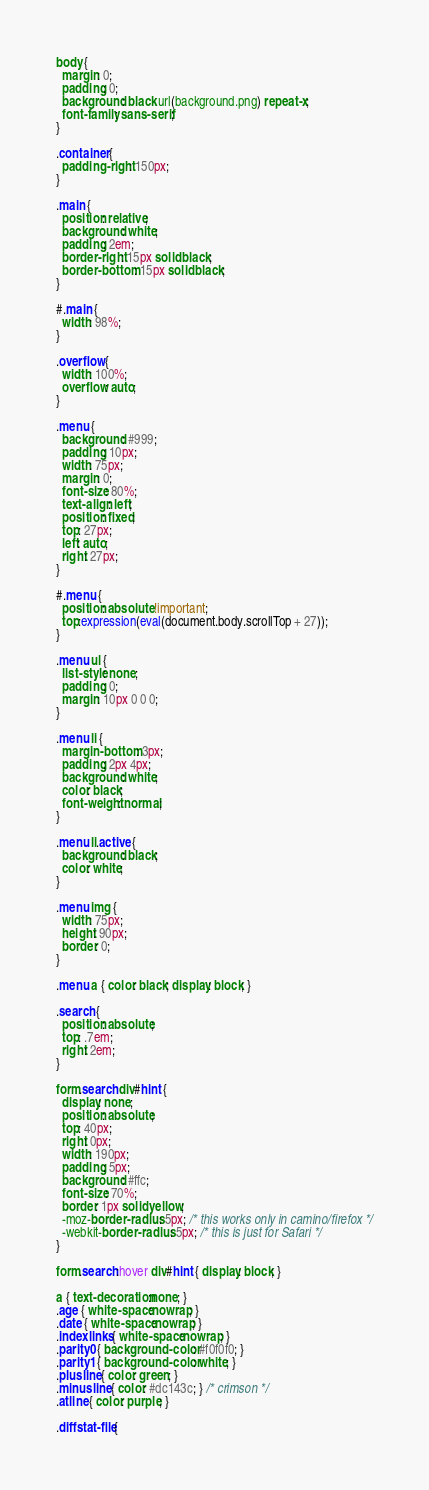<code> <loc_0><loc_0><loc_500><loc_500><_CSS_>body {
  margin: 0;
  padding: 0;
  background: black url(background.png) repeat-x;
  font-family: sans-serif;
}

.container {
  padding-right: 150px;
}

.main {
  position: relative;
  background: white;
  padding: 2em;
  border-right: 15px solid black;
  border-bottom: 15px solid black;
}

#.main {
  width: 98%;
}

.overflow {
  width: 100%;
  overflow: auto;
}

.menu {
  background: #999;
  padding: 10px;
  width: 75px;
  margin: 0;
  font-size: 80%;
  text-align: left;
  position: fixed;
  top: 27px;
  left: auto;
  right: 27px;
}

#.menu {
  position: absolute !important;
  top:expression(eval(document.body.scrollTop + 27));
}

.menu ul {
  list-style: none;
  padding: 0;
  margin: 10px 0 0 0;
}

.menu li {
  margin-bottom: 3px;
  padding: 2px 4px;
  background: white;
  color: black;
  font-weight: normal;
}

.menu li.active {
  background: black;
  color: white;
}

.menu img {
  width: 75px;
  height: 90px;
  border: 0;
}

.menu a { color: black; display: block; }

.search {
  position: absolute;
  top: .7em;
  right: 2em;
}

form.search div#hint {
  display: none;
  position: absolute;
  top: 40px;
  right: 0px;
  width: 190px;
  padding: 5px;
  background: #ffc;
  font-size: 70%;
  border: 1px solid yellow;
  -moz-border-radius: 5px; /* this works only in camino/firefox */
  -webkit-border-radius: 5px; /* this is just for Safari */
}

form.search:hover div#hint { display: block; }

a { text-decoration:none; }
.age { white-space:nowrap; }
.date { white-space:nowrap; }
.indexlinks { white-space:nowrap; }
.parity0 { background-color: #f0f0f0; }
.parity1 { background-color: white; }
.plusline { color: green; }
.minusline { color: #dc143c; } /* crimson */
.atline { color: purple; }

.diffstat-file {</code> 